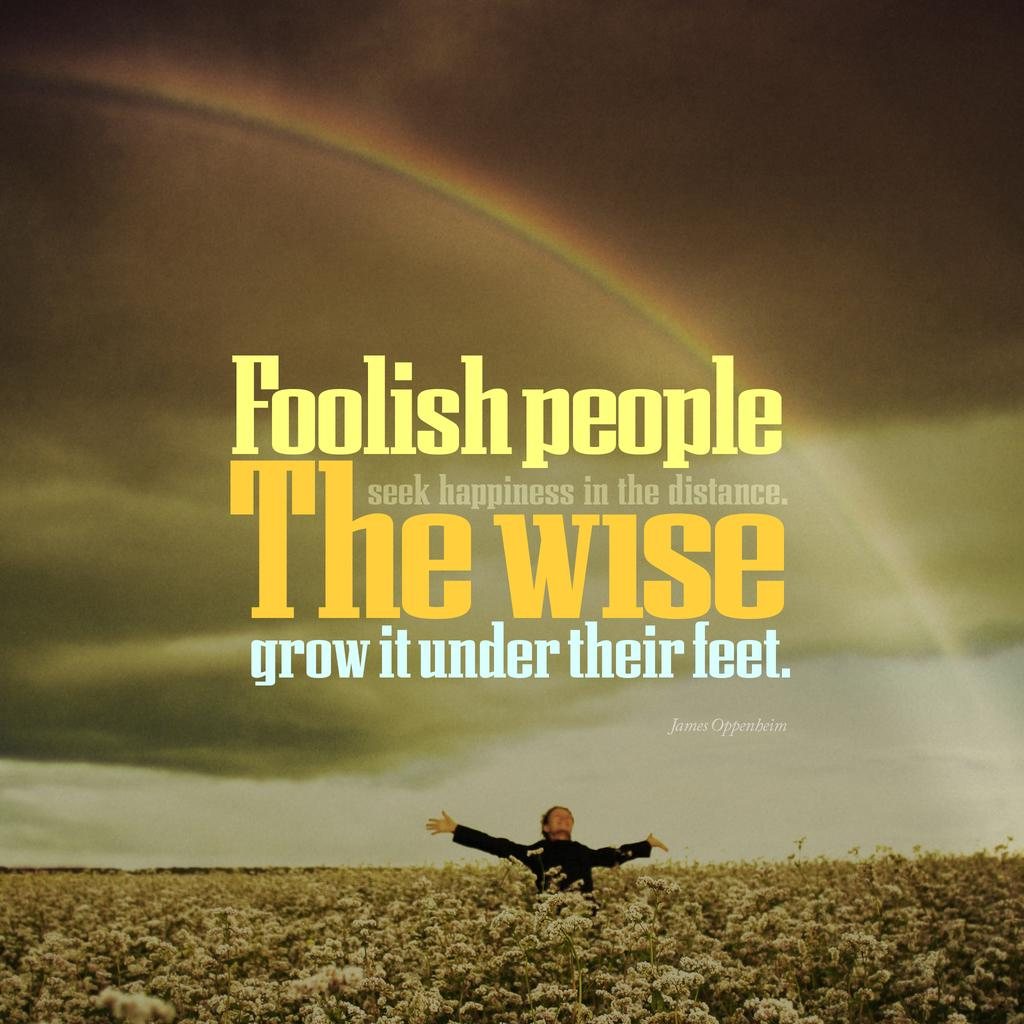<image>
Offer a succinct explanation of the picture presented. A quote by James Oppenheim -"Foolish people seek happiness in the distance. The wise grow it under their feet ." 